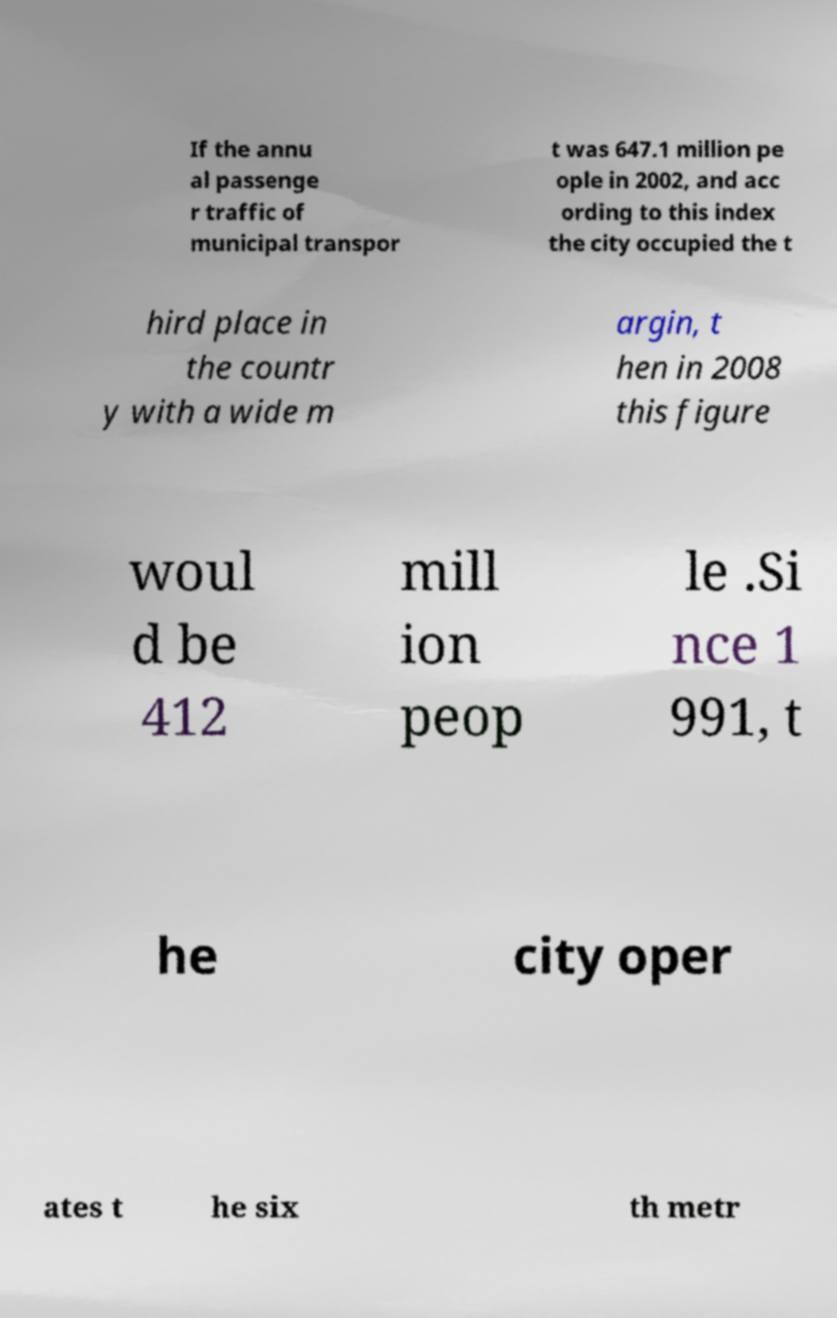Could you extract and type out the text from this image? If the annu al passenge r traffic of municipal transpor t was 647.1 million pe ople in 2002, and acc ording to this index the city occupied the t hird place in the countr y with a wide m argin, t hen in 2008 this figure woul d be 412 mill ion peop le .Si nce 1 991, t he city oper ates t he six th metr 